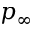Convert formula to latex. <formula><loc_0><loc_0><loc_500><loc_500>p _ { \infty }</formula> 